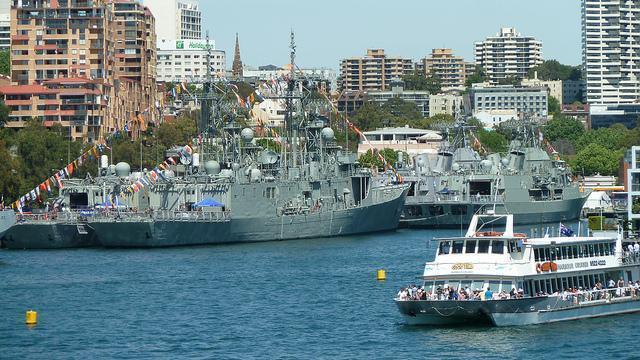What vehicle used for this water transportation?
Make your selection from the four choices given to correctly answer the question.
Options: Yacht, canoe, cargo ship, raft boat. Cargo ship. 